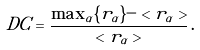Convert formula to latex. <formula><loc_0><loc_0><loc_500><loc_500>D C = \frac { \max _ { \alpha } \{ r _ { \alpha } \} - < r _ { \alpha } > } { < r _ { \alpha } > } \, .</formula> 